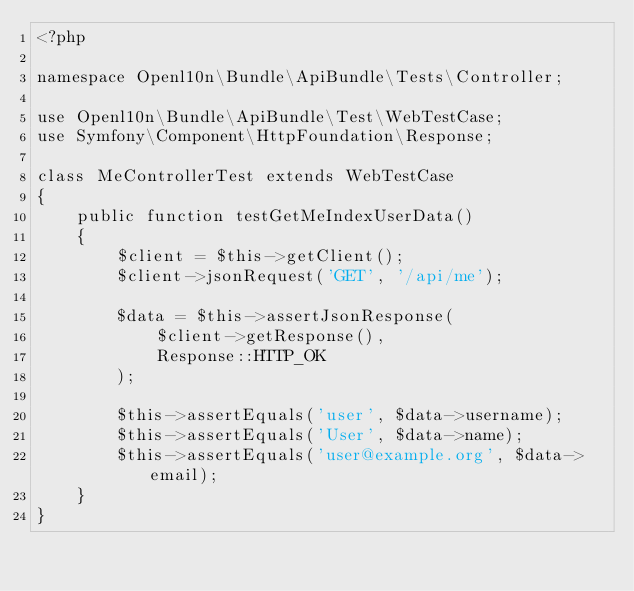<code> <loc_0><loc_0><loc_500><loc_500><_PHP_><?php

namespace Openl10n\Bundle\ApiBundle\Tests\Controller;

use Openl10n\Bundle\ApiBundle\Test\WebTestCase;
use Symfony\Component\HttpFoundation\Response;

class MeControllerTest extends WebTestCase
{
    public function testGetMeIndexUserData()
    {
        $client = $this->getClient();
        $client->jsonRequest('GET', '/api/me');

        $data = $this->assertJsonResponse(
            $client->getResponse(),
            Response::HTTP_OK
        );

        $this->assertEquals('user', $data->username);
        $this->assertEquals('User', $data->name);
        $this->assertEquals('user@example.org', $data->email);
    }
}
</code> 